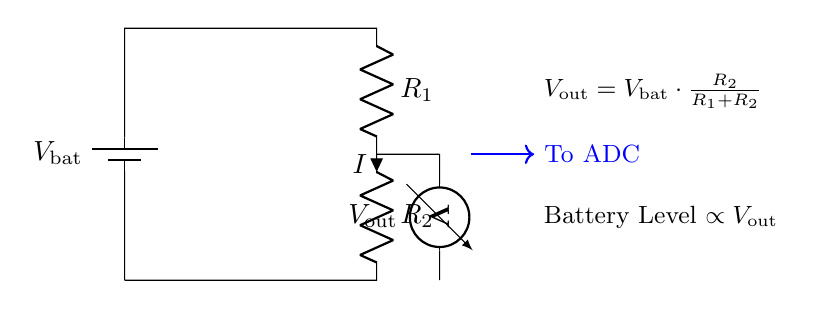What type of circuit is this? The circuit represents a voltage-divider bridge circuit designed to monitor battery levels. It divides the input voltage to create a lower voltage output that can be measured.
Answer: Voltage-divider bridge What components are present in the circuit? The circuit includes a battery, two resistors (R1 and R2), a voltmeter for measuring the output voltage, and connections to indicate current flow.
Answer: Battery, R1, R2, voltmeter What is the output voltage formula? The output voltage (Vout) can be calculated using the formula Vout = Vbat multiplied by R2 divided by (R1 plus R2), which describes how the resistors affect the output.
Answer: Vout = Vbat * R2 / (R1 + R2) What does Vout represent in relation to the battery level? Vout is proportional to the battery level, indicating that as the battery discharges, the output voltage will decrease, reflecting the lower energy level in the battery.
Answer: Proportional to battery level What current direction is indicated in the circuit? The current flows from the positive terminal of the battery, through R1 and R2 in series, and returns to the negative terminal, as indicated by the current arrow pointing down through R2.
Answer: Down through R2 How does changing R1 affect Vout? Increasing R1 will lower Vout because, based on the voltage-divider formula, a larger resistance in the numerator (R1) relative to R2 will reduce the fraction of Vbat that appears at the output.
Answer: Vout decreases 